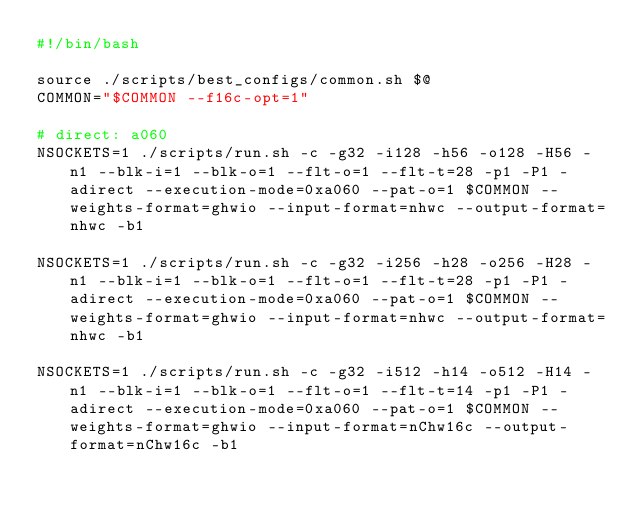Convert code to text. <code><loc_0><loc_0><loc_500><loc_500><_Bash_>#!/bin/bash

source ./scripts/best_configs/common.sh $@
COMMON="$COMMON --f16c-opt=1"

# direct: a060
NSOCKETS=1 ./scripts/run.sh -c -g32 -i128 -h56 -o128 -H56 -n1 --blk-i=1 --blk-o=1 --flt-o=1 --flt-t=28 -p1 -P1 -adirect --execution-mode=0xa060 --pat-o=1 $COMMON --weights-format=ghwio --input-format=nhwc --output-format=nhwc -b1

NSOCKETS=1 ./scripts/run.sh -c -g32 -i256 -h28 -o256 -H28 -n1 --blk-i=1 --blk-o=1 --flt-o=1 --flt-t=28 -p1 -P1 -adirect --execution-mode=0xa060 --pat-o=1 $COMMON --weights-format=ghwio --input-format=nhwc --output-format=nhwc -b1

NSOCKETS=1 ./scripts/run.sh -c -g32 -i512 -h14 -o512 -H14 -n1 --blk-i=1 --blk-o=1 --flt-o=1 --flt-t=14 -p1 -P1 -adirect --execution-mode=0xa060 --pat-o=1 $COMMON --weights-format=ghwio --input-format=nChw16c --output-format=nChw16c -b1
</code> 